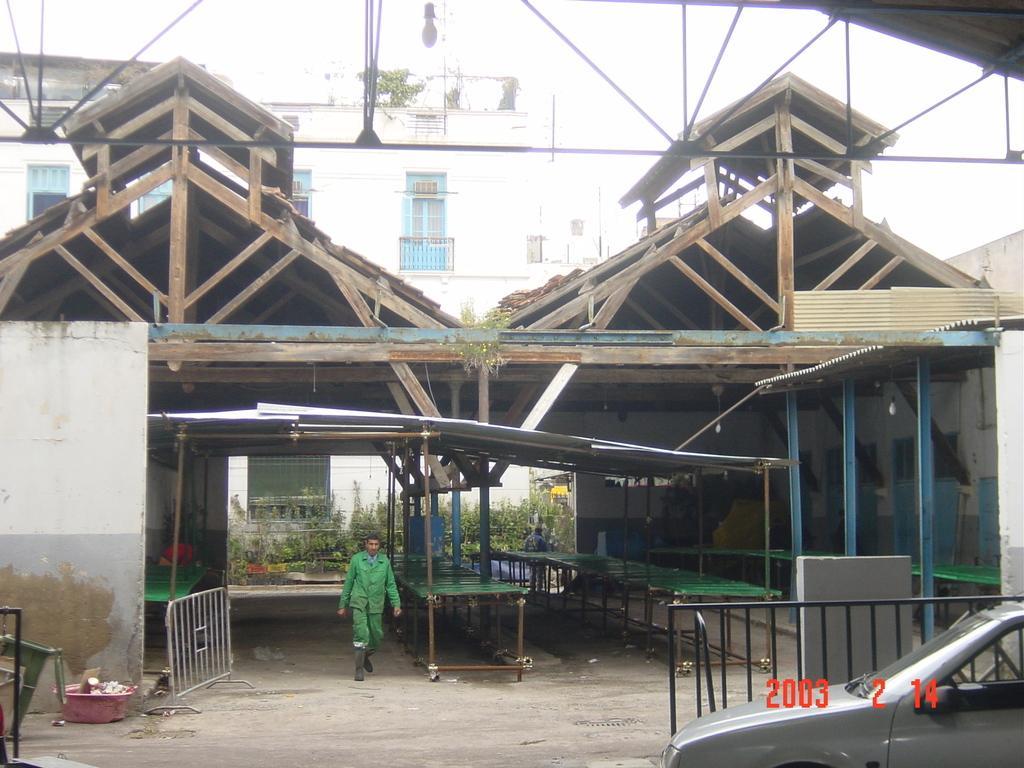Can you describe this image briefly? Here in this picture we can see a wooden shed present on the ground over there and in that we can see tables present on the ground and we can see people standing and walking over there and behind that we can see buildings present and we can see present on the middle, on the ground over there. 